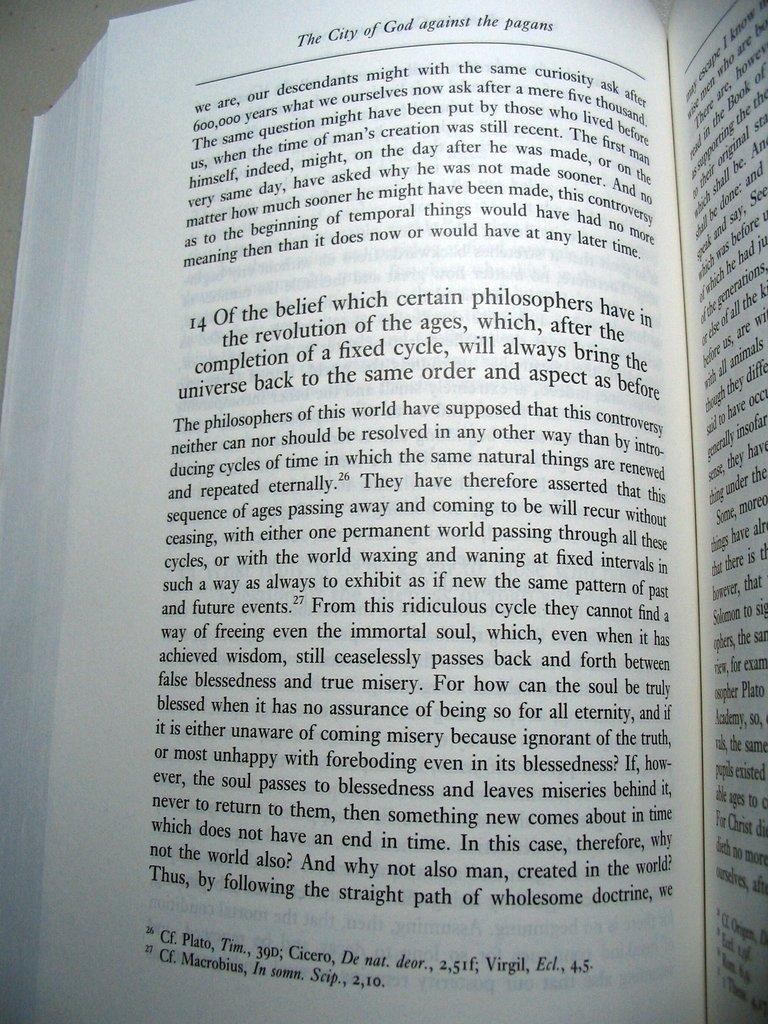What is the title of this book?
Your answer should be very brief. The city of god against the pagans. 